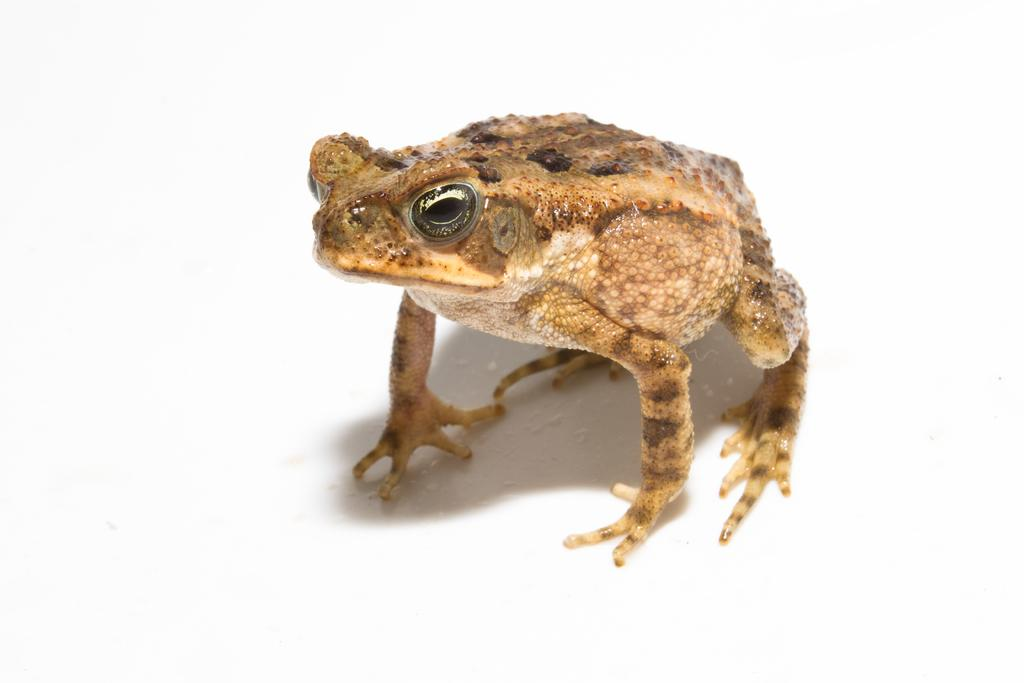What type of animal is present in the image? There is a frog in the image. What is the frog's opinion on the current political climate in the image? There is no indication in the image that the frog has any opinions or thoughts, as it is an animal and cannot express such ideas. 